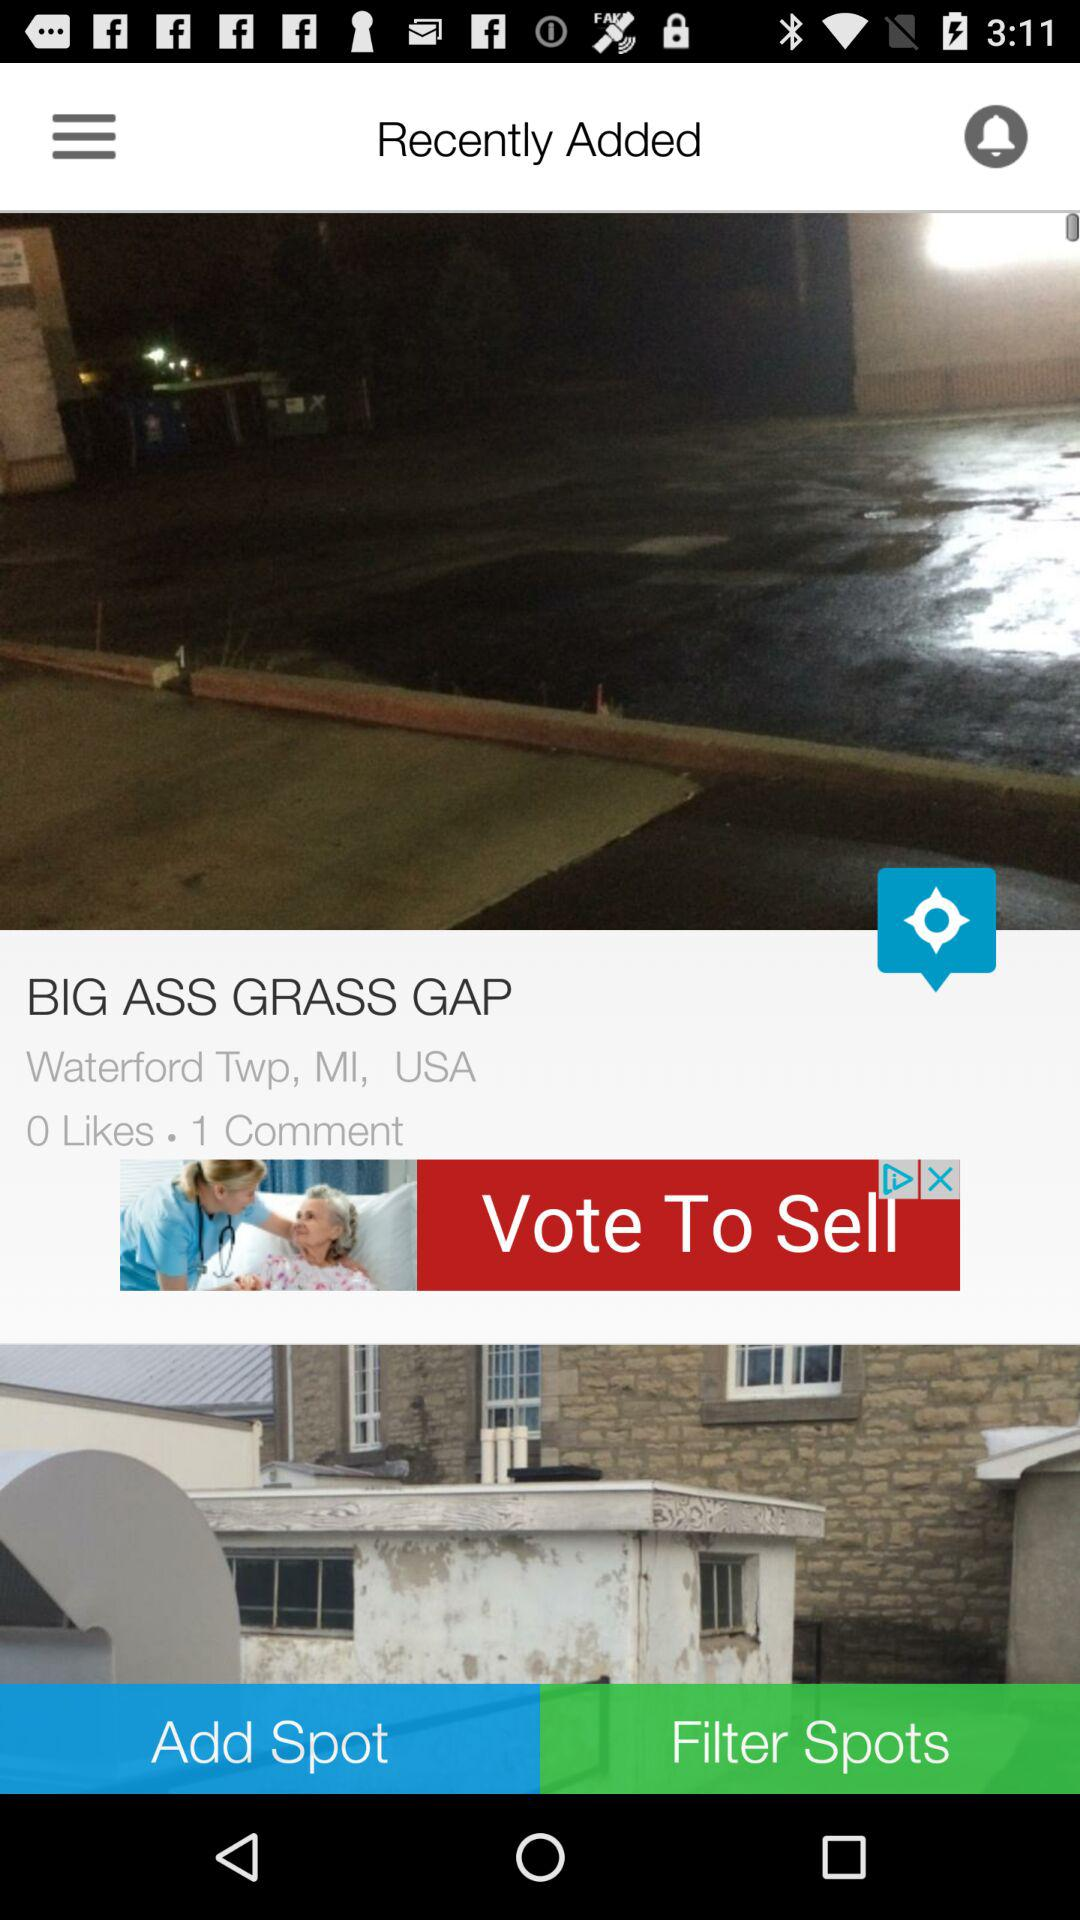What is the location? The location is Waterford Twp, MI, USA. 